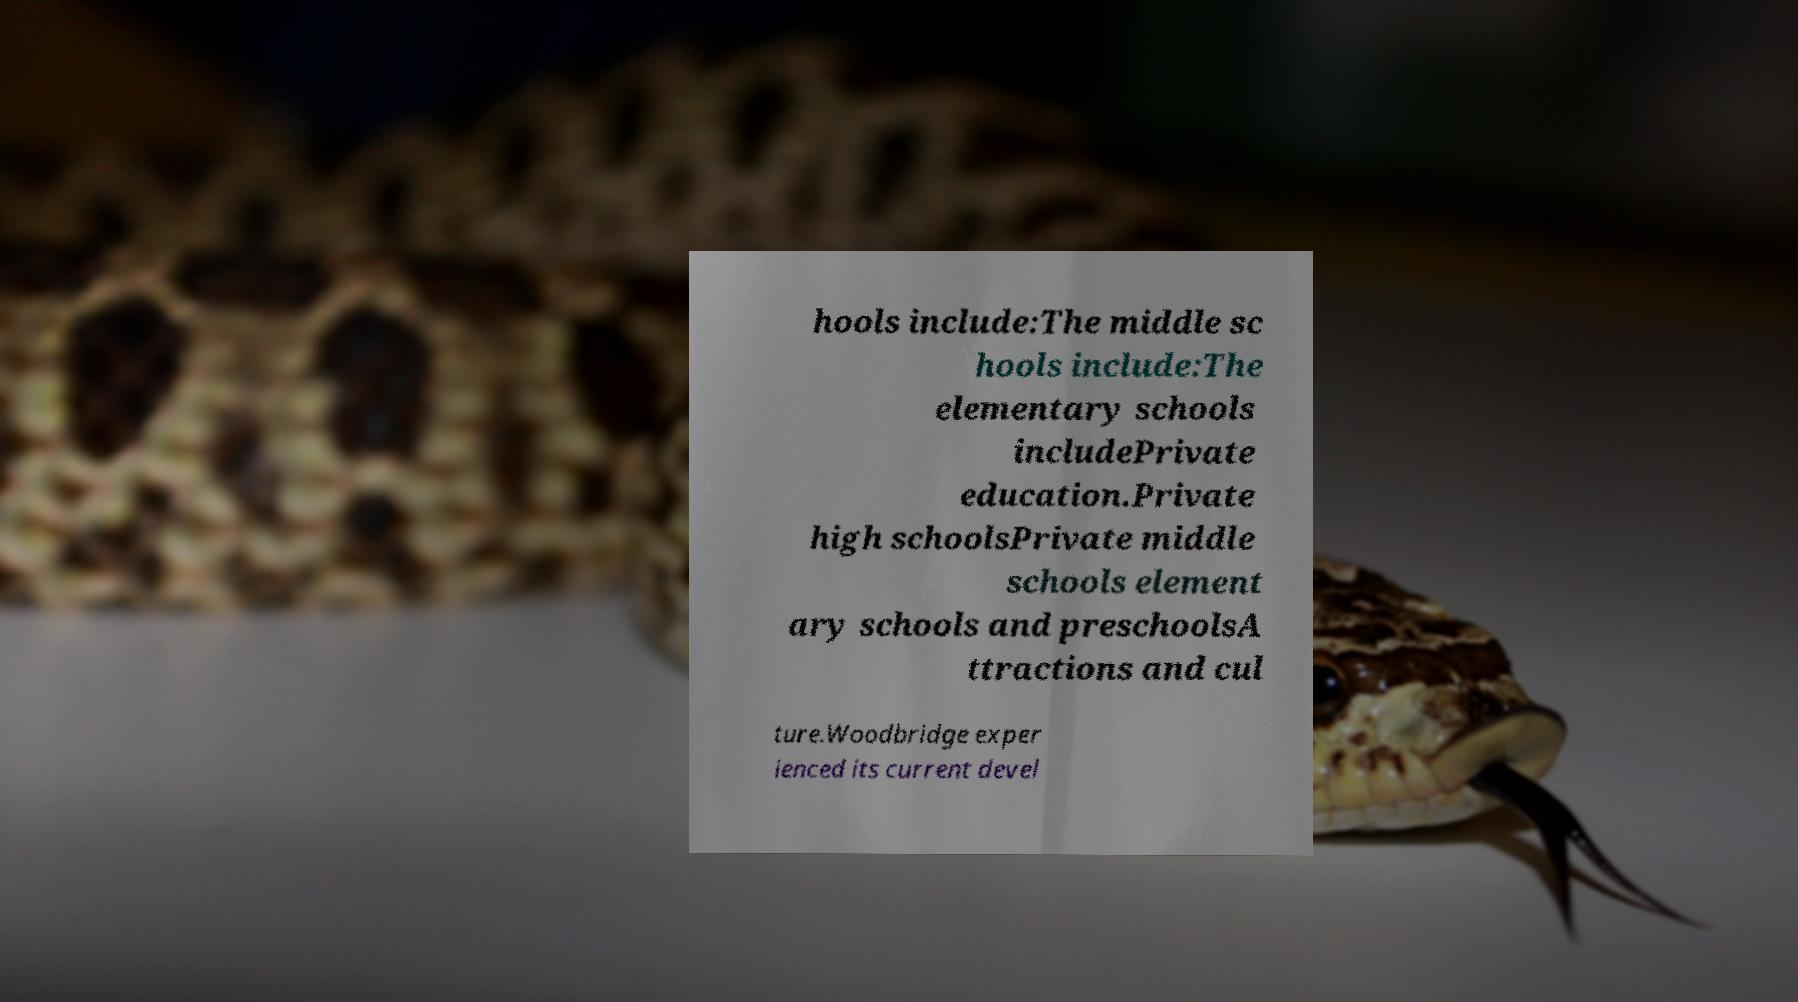Can you read and provide the text displayed in the image?This photo seems to have some interesting text. Can you extract and type it out for me? hools include:The middle sc hools include:The elementary schools includePrivate education.Private high schoolsPrivate middle schools element ary schools and preschoolsA ttractions and cul ture.Woodbridge exper ienced its current devel 